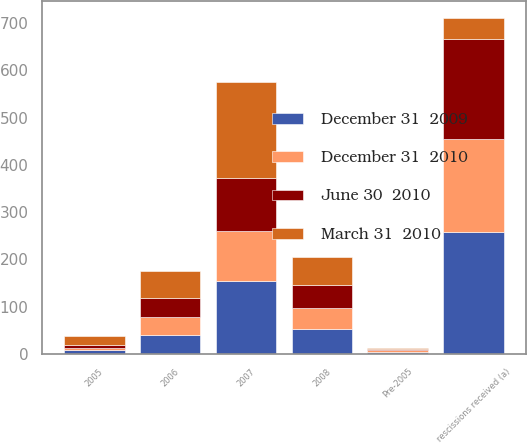<chart> <loc_0><loc_0><loc_500><loc_500><stacked_bar_chart><ecel><fcel>Pre-2005<fcel>2005<fcel>2006<fcel>2007<fcel>2008<fcel>rescissions received (a)<nl><fcel>June 30  2010<fcel>3<fcel>7<fcel>40<fcel>113<fcel>49<fcel>213<nl><fcel>December 31  2010<fcel>4<fcel>5<fcel>39<fcel>105<fcel>44<fcel>197<nl><fcel>December 31  2009<fcel>4<fcel>7<fcel>39<fcel>155<fcel>52<fcel>257<nl><fcel>March 31  2010<fcel>2<fcel>18<fcel>57<fcel>203<fcel>60<fcel>44<nl></chart> 